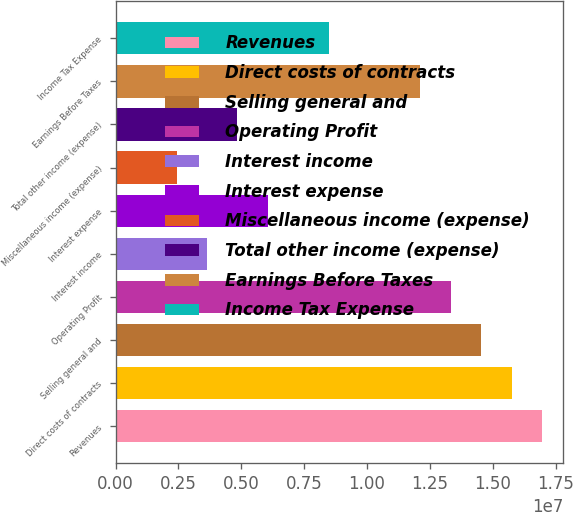<chart> <loc_0><loc_0><loc_500><loc_500><bar_chart><fcel>Revenues<fcel>Direct costs of contracts<fcel>Selling general and<fcel>Operating Profit<fcel>Interest income<fcel>Interest expense<fcel>Miscellaneous income (expense)<fcel>Total other income (expense)<fcel>Earnings Before Taxes<fcel>Income Tax Expense<nl><fcel>1.69608e+07<fcel>1.57493e+07<fcel>1.45378e+07<fcel>1.33263e+07<fcel>3.63445e+06<fcel>6.05742e+06<fcel>2.42297e+06<fcel>4.84593e+06<fcel>1.21148e+07<fcel>8.48038e+06<nl></chart> 